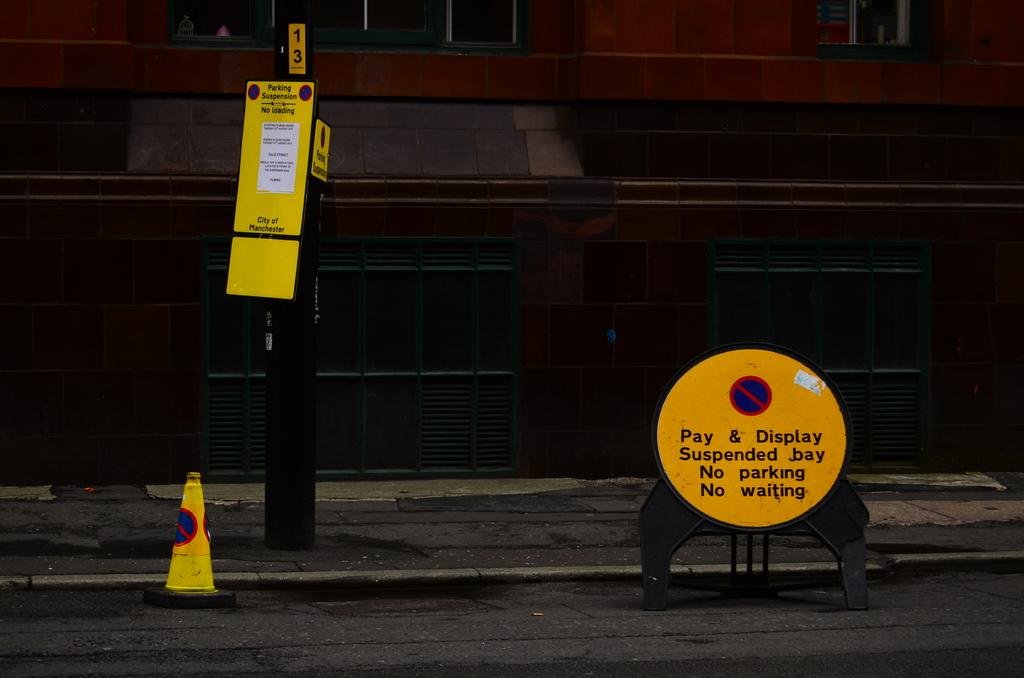<image>
Summarize the visual content of the image. A few signs are displayed on the street, one stating Pay & Display Suspended bay No parking No waiting. 